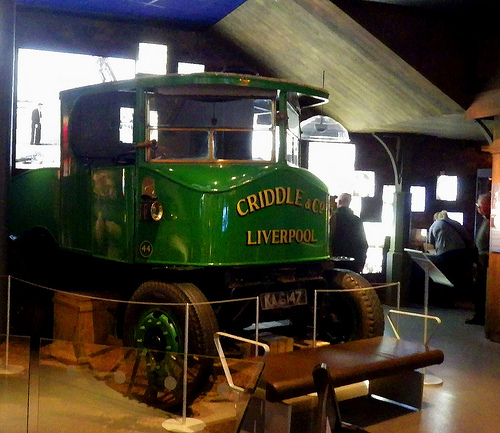<image>
Is there a wheel to the left of the wheel? Yes. From this viewpoint, the wheel is positioned to the left side relative to the wheel. 